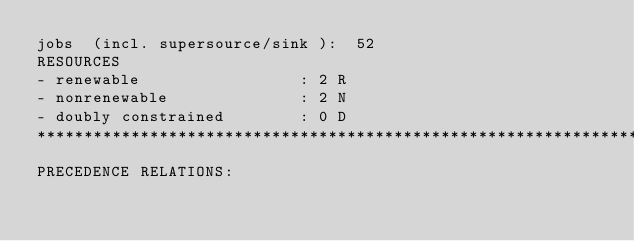Convert code to text. <code><loc_0><loc_0><loc_500><loc_500><_ObjectiveC_>jobs  (incl. supersource/sink ):	52
RESOURCES
- renewable                 : 2 R
- nonrenewable              : 2 N
- doubly constrained        : 0 D
************************************************************************
PRECEDENCE RELATIONS:</code> 